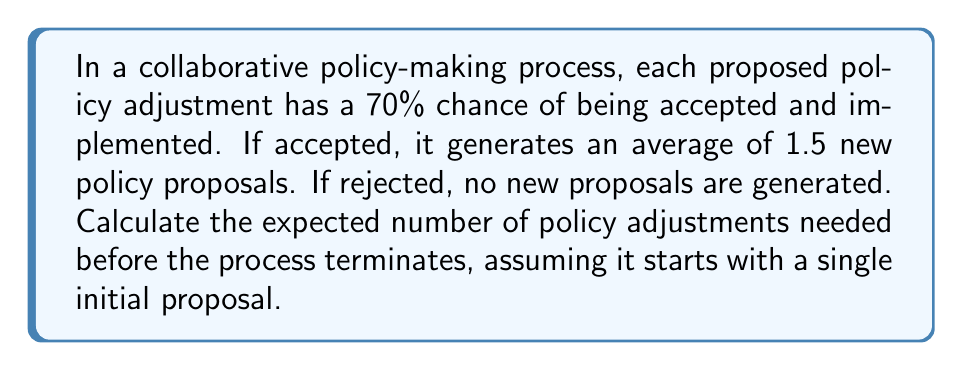What is the answer to this math problem? Let's approach this using a branching process model:

1) Let $X$ be the random variable representing the number of policy adjustments.

2) The probability of success (acceptance) is $p = 0.7$, and the mean number of new proposals generated upon success is $m = 1.5$.

3) The expected number of "offspring" (new proposals) per proposal is:
   $$\mu = p \cdot m = 0.7 \cdot 1.5 = 1.05$$

4) In a branching process, the expected total number of individuals (including the initial one) is given by:
   $$E[X] = \frac{1}{1-\mu}$$
   if $\mu < 1$, and infinite if $\mu \geq 1$.

5) In our case, $\mu = 1.05 > 1$, which means the process is supercritical.

6) For a supercritical process, the expected number of policy adjustments is infinite. This means that, on average, the process will continue indefinitely, constantly generating new policy proposals.

7) Intuitively, this makes sense because each proposal generates, on average, 1.05 new proposals, which is more than enough to sustain and grow the process.
Answer: $\infty$ (infinity) 